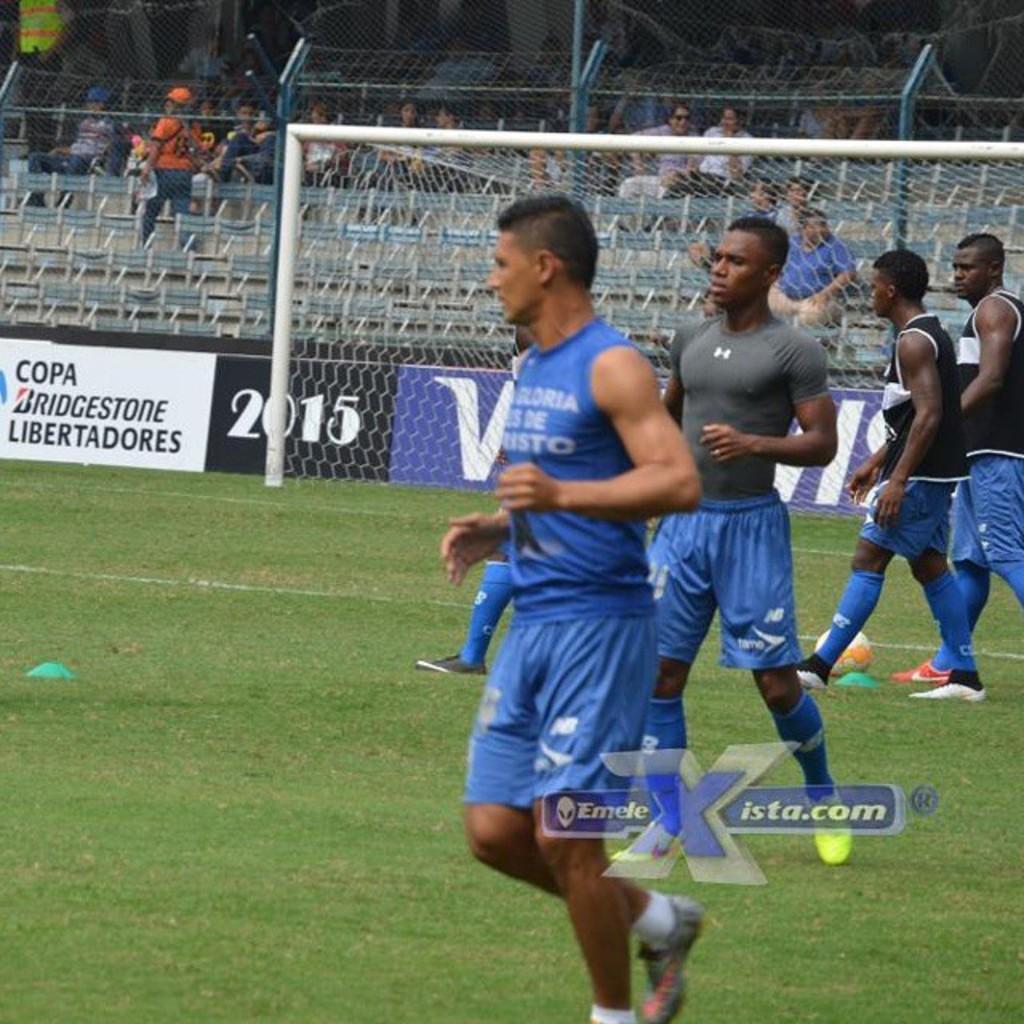Describe this image in one or two sentences. In this image in front there are people walking on the grass. Behind them there is a metal fence. There is a banner. In the background of the image there are people sitting on the chairs. 